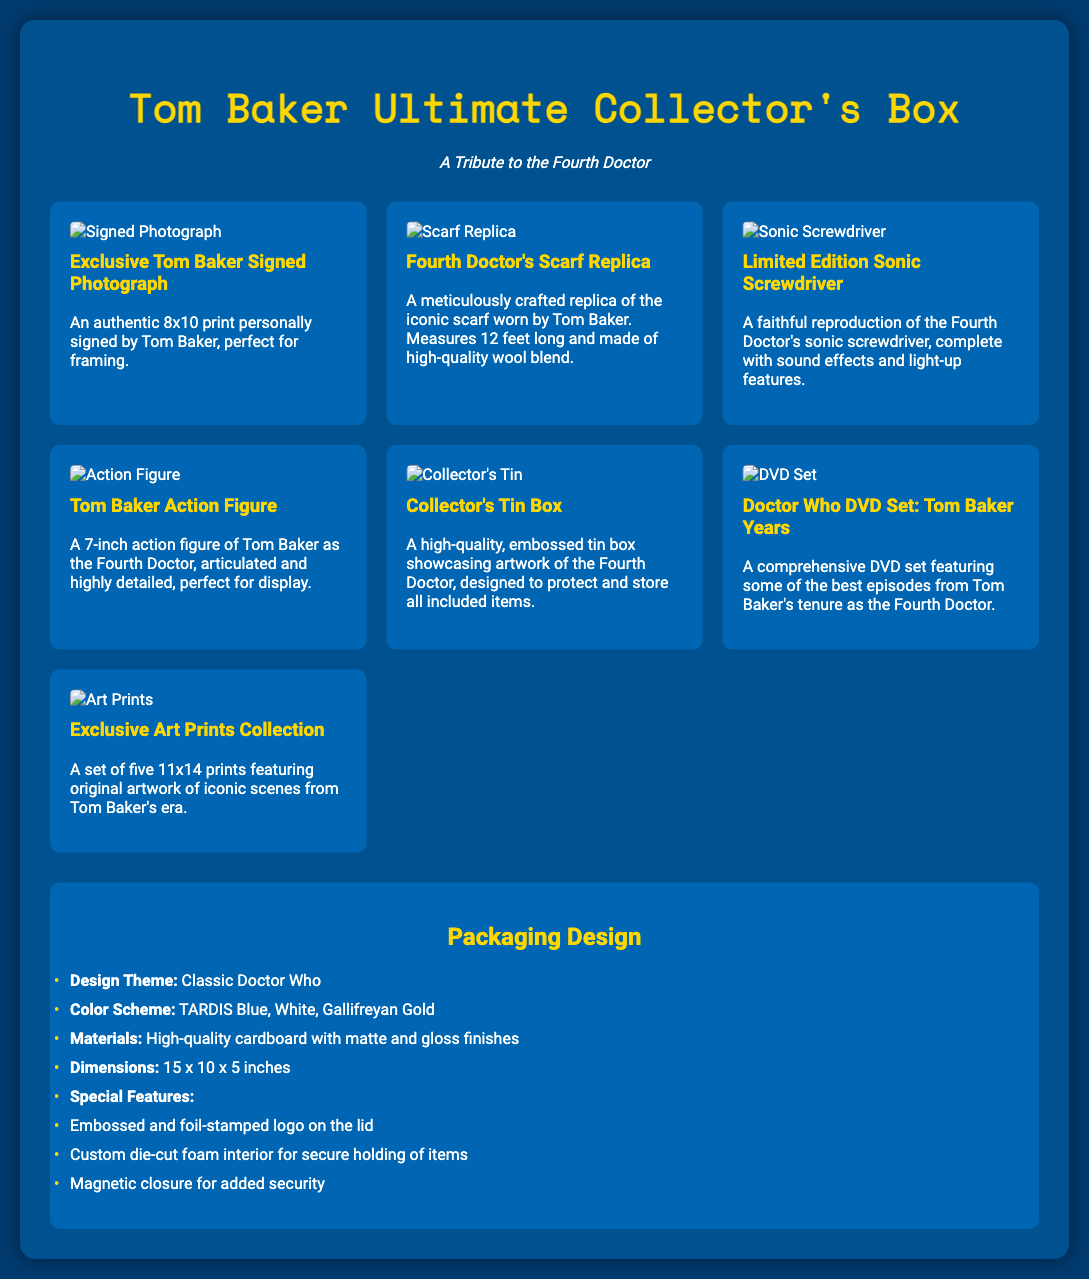what is the title of the collector's box? The title of the collector's box is stated at the top of the document as "Tom Baker Ultimate Collector's Box."
Answer: Tom Baker Ultimate Collector's Box how many items are included in the collector's box? The document lists seven distinct items included in the collector's box.
Answer: 7 what is the length of the Fourth Doctor's scarf replica? The scarf replica measures 12 feet long, as mentioned in the description.
Answer: 12 feet what feature secures the contents of the packaging? The packaging has a magnetic closure to ensure the items are securely held in place.
Answer: Magnetic closure what color scheme is used in the packaging design? The color scheme includes TARDIS Blue, White, and Gallifreyan Gold, as described in the packaging section.
Answer: TARDIS Blue, White, Gallifreyan Gold what type of material is used for the collector's tin box? The collector's tin box is made of high-quality, embossed tin.
Answer: Embossed tin which item is described as "an authentic 8x10 print personally signed by Tom Baker"? This description refers to the "Exclusive Tom Baker Signed Photograph."
Answer: Exclusive Tom Baker Signed Photograph what is the design theme of the packaging? The design theme mentioned in the document is "Classic Doctor Who."
Answer: Classic Doctor Who 